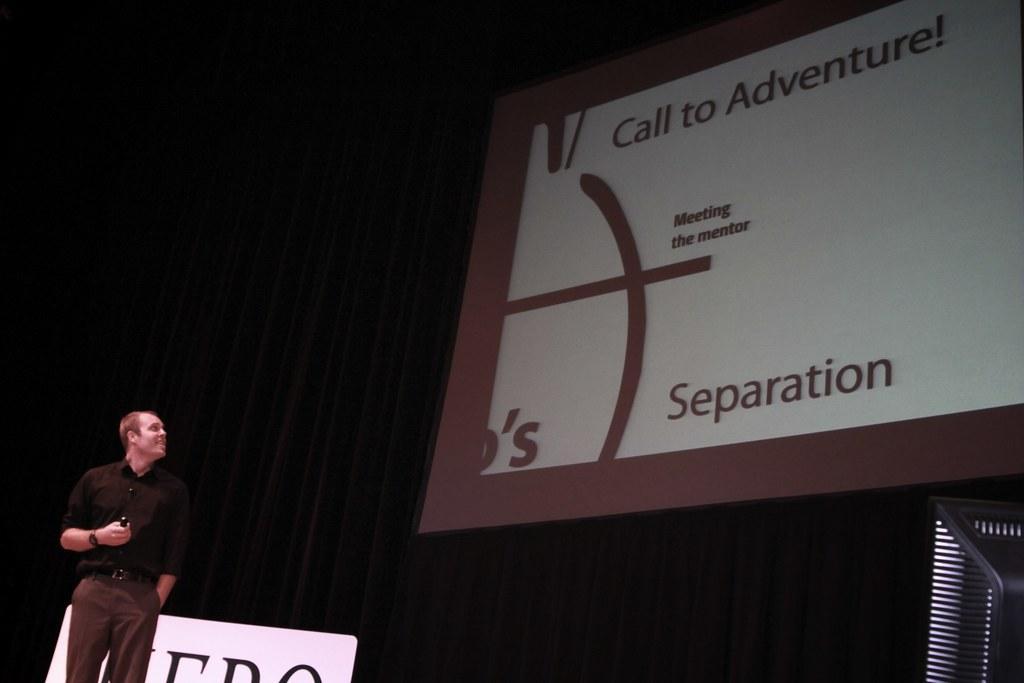How would you summarize this image in a sentence or two? In this picture I can observe a person on the left side. On the right side there is a screen. In the background I can observe black color curtain. 